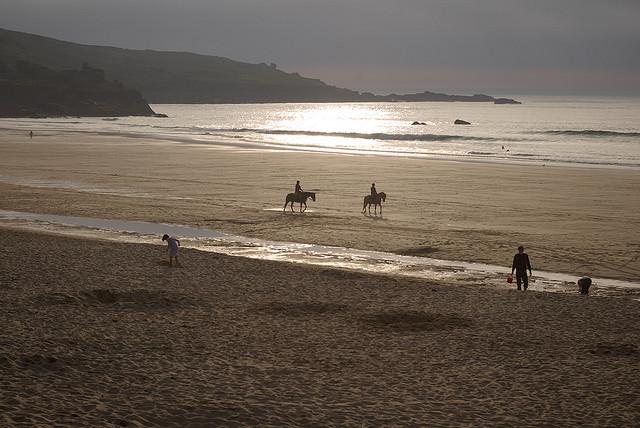What animals are visible?
Give a very brief answer. Horses. Is the beach water foamy?
Concise answer only. No. Is there a lot of sand in the image?
Concise answer only. Yes. Are the horses' hooves wet?
Concise answer only. Yes. What are they on?
Keep it brief. Horses. 